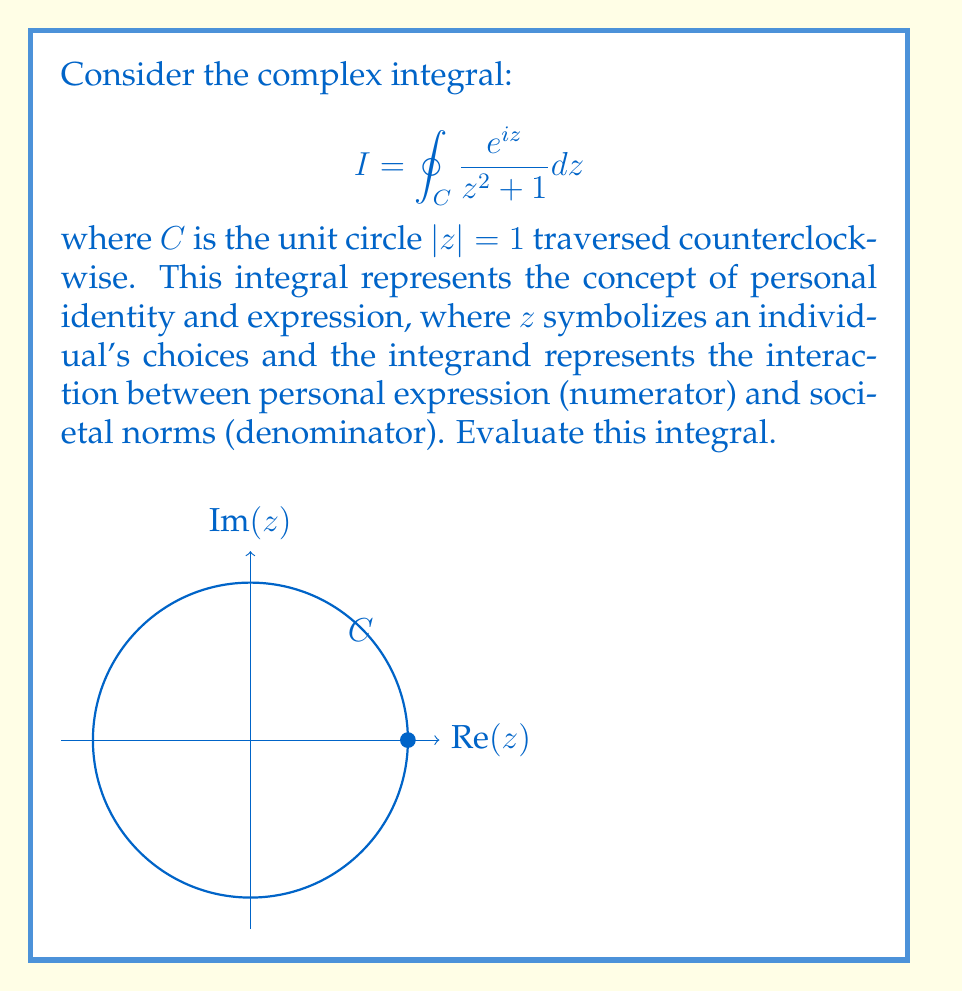Give your solution to this math problem. To evaluate this integral, we'll use the Residue Theorem:

1) First, identify the poles inside the unit circle:
   The poles are at $z = \pm i$, but only $z = i$ is inside $C$.

2) Calculate the residue at $z = i$:
   $$ \text{Res}(f,i) = \lim_{z \to i} (z-i)\frac{e^{iz}}{z^2 + 1} $$
   
   Using L'Hôpital's rule:
   $$ \text{Res}(f,i) = \lim_{z \to i} \frac{e^{iz}}{2z} = \frac{e^{-1}}{2i} $$

3) Apply the Residue Theorem:
   $$ I = 2\pi i \cdot \text{Res}(f,i) = 2\pi i \cdot \frac{e^{-1}}{2i} = \pi e^{-1} $$

This result symbolizes how personal expression (represented by $e^{iz}$) interacts with societal norms ($z^2 + 1$) to form a coherent identity ($\pi e^{-1}$).
Answer: $\pi e^{-1}$ 